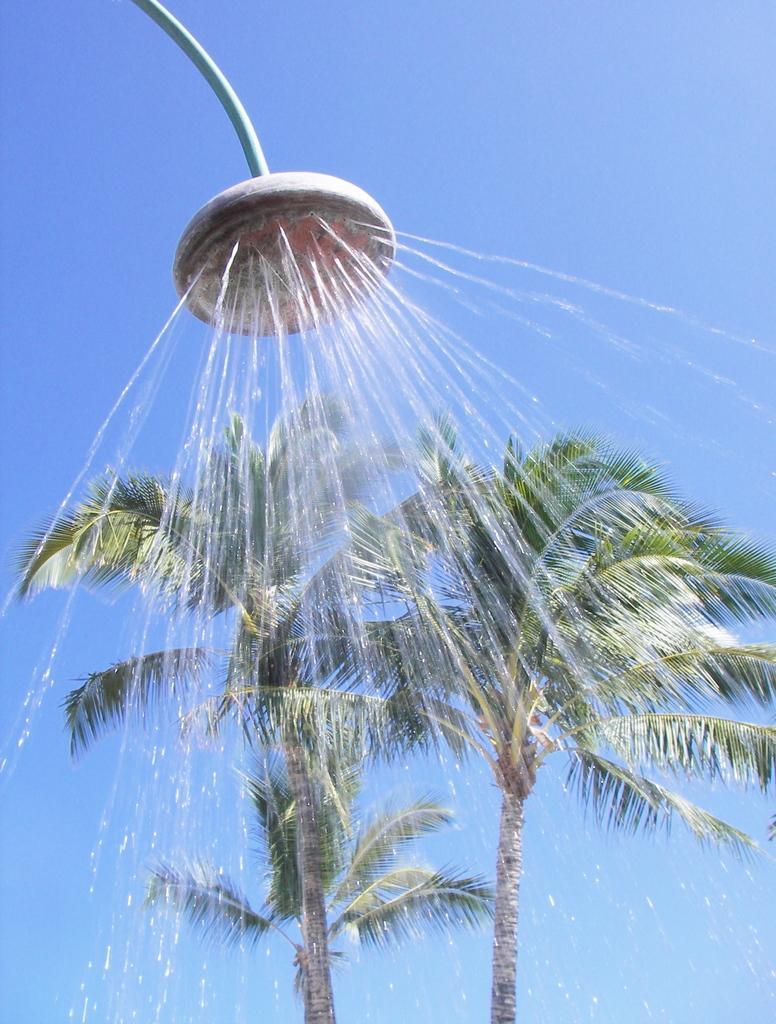Describe this image in one or two sentences. In this image there are two trees on the bottom of this image and there is a shower on the top of this image and there is a blue sky in the background. 